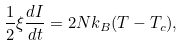<formula> <loc_0><loc_0><loc_500><loc_500>\frac { 1 } { 2 } \xi \frac { d I } { d t } = 2 N k _ { B } ( T - T _ { c } ) ,</formula> 